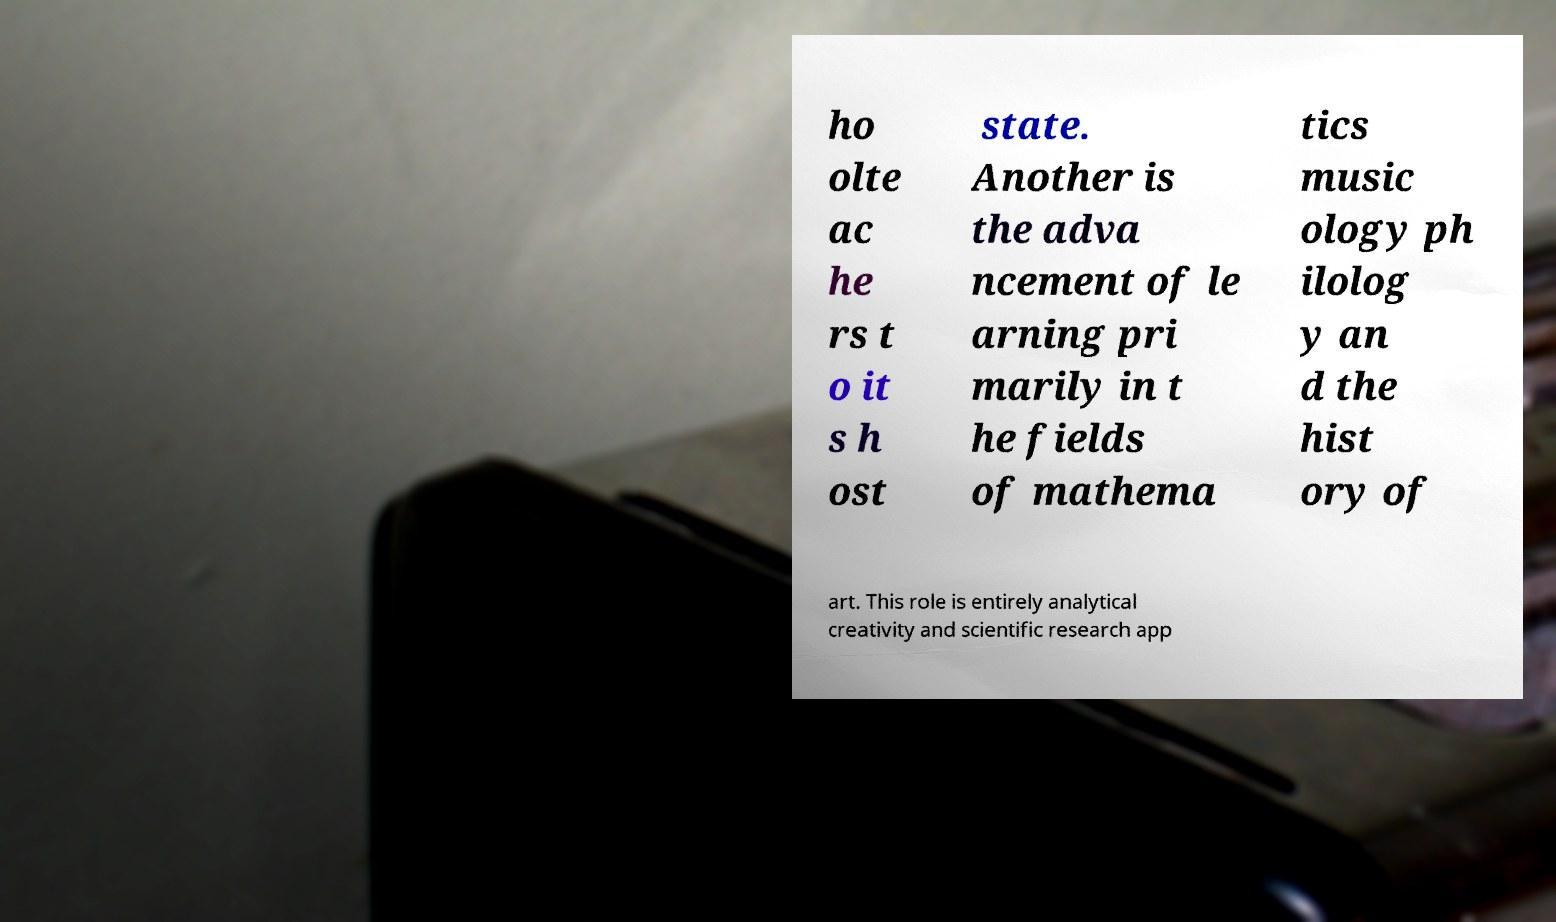For documentation purposes, I need the text within this image transcribed. Could you provide that? ho olte ac he rs t o it s h ost state. Another is the adva ncement of le arning pri marily in t he fields of mathema tics music ology ph ilolog y an d the hist ory of art. This role is entirely analytical creativity and scientific research app 